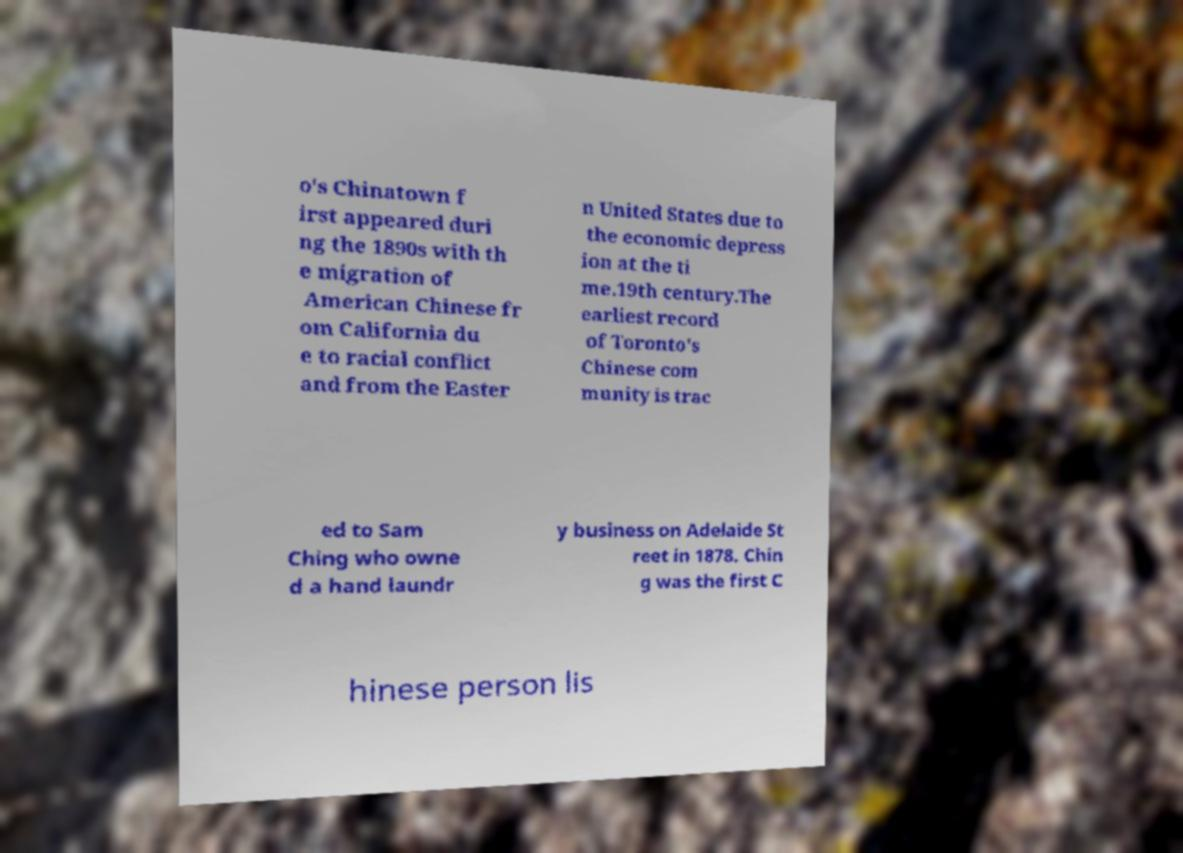Please read and relay the text visible in this image. What does it say? o's Chinatown f irst appeared duri ng the 1890s with th e migration of American Chinese fr om California du e to racial conflict and from the Easter n United States due to the economic depress ion at the ti me.19th century.The earliest record of Toronto's Chinese com munity is trac ed to Sam Ching who owne d a hand laundr y business on Adelaide St reet in 1878. Chin g was the first C hinese person lis 